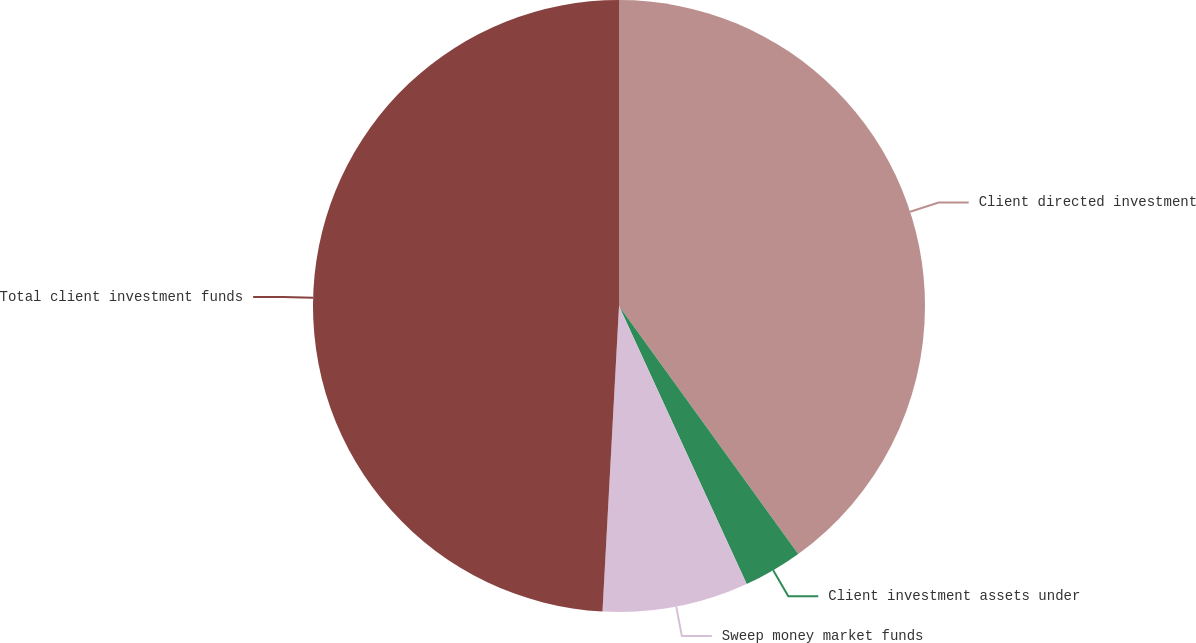Convert chart to OTSL. <chart><loc_0><loc_0><loc_500><loc_500><pie_chart><fcel>Client directed investment<fcel>Client investment assets under<fcel>Sweep money market funds<fcel>Total client investment funds<nl><fcel>40.04%<fcel>3.11%<fcel>7.71%<fcel>49.14%<nl></chart> 